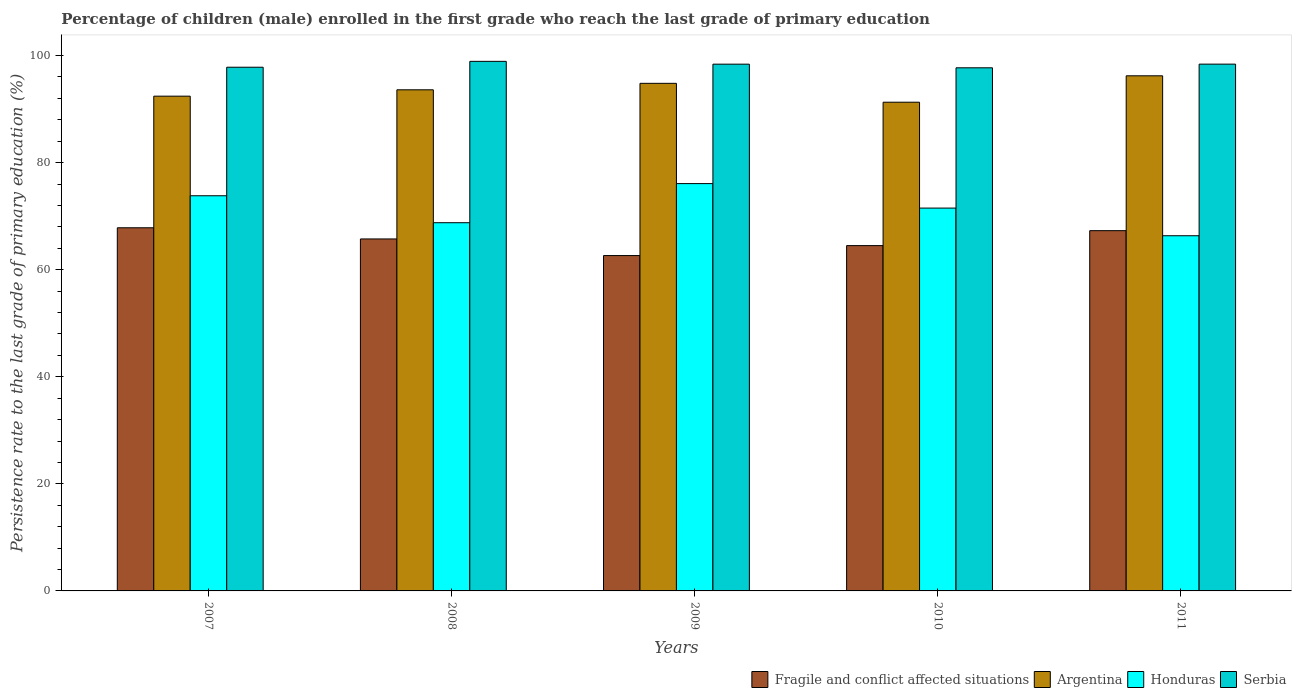How many bars are there on the 4th tick from the left?
Make the answer very short. 4. In how many cases, is the number of bars for a given year not equal to the number of legend labels?
Your response must be concise. 0. What is the persistence rate of children in Serbia in 2009?
Provide a succinct answer. 98.39. Across all years, what is the maximum persistence rate of children in Fragile and conflict affected situations?
Keep it short and to the point. 67.83. Across all years, what is the minimum persistence rate of children in Fragile and conflict affected situations?
Provide a succinct answer. 62.64. In which year was the persistence rate of children in Fragile and conflict affected situations minimum?
Provide a short and direct response. 2009. What is the total persistence rate of children in Fragile and conflict affected situations in the graph?
Your answer should be compact. 327.99. What is the difference between the persistence rate of children in Honduras in 2007 and that in 2011?
Offer a very short reply. 7.47. What is the difference between the persistence rate of children in Argentina in 2008 and the persistence rate of children in Fragile and conflict affected situations in 2010?
Keep it short and to the point. 29.1. What is the average persistence rate of children in Serbia per year?
Provide a succinct answer. 98.24. In the year 2011, what is the difference between the persistence rate of children in Honduras and persistence rate of children in Fragile and conflict affected situations?
Your answer should be compact. -0.95. In how many years, is the persistence rate of children in Fragile and conflict affected situations greater than 12 %?
Offer a terse response. 5. What is the ratio of the persistence rate of children in Honduras in 2009 to that in 2011?
Ensure brevity in your answer.  1.15. Is the difference between the persistence rate of children in Honduras in 2008 and 2011 greater than the difference between the persistence rate of children in Fragile and conflict affected situations in 2008 and 2011?
Provide a short and direct response. Yes. What is the difference between the highest and the second highest persistence rate of children in Serbia?
Ensure brevity in your answer.  0.52. What is the difference between the highest and the lowest persistence rate of children in Honduras?
Your answer should be compact. 9.74. In how many years, is the persistence rate of children in Fragile and conflict affected situations greater than the average persistence rate of children in Fragile and conflict affected situations taken over all years?
Offer a very short reply. 3. Is it the case that in every year, the sum of the persistence rate of children in Serbia and persistence rate of children in Argentina is greater than the sum of persistence rate of children in Fragile and conflict affected situations and persistence rate of children in Honduras?
Provide a short and direct response. Yes. What does the 4th bar from the left in 2007 represents?
Give a very brief answer. Serbia. What does the 4th bar from the right in 2010 represents?
Make the answer very short. Fragile and conflict affected situations. Is it the case that in every year, the sum of the persistence rate of children in Fragile and conflict affected situations and persistence rate of children in Serbia is greater than the persistence rate of children in Honduras?
Your answer should be very brief. Yes. How many bars are there?
Give a very brief answer. 20. Are all the bars in the graph horizontal?
Your answer should be very brief. No. How many years are there in the graph?
Your response must be concise. 5. Does the graph contain any zero values?
Make the answer very short. No. How are the legend labels stacked?
Provide a succinct answer. Horizontal. What is the title of the graph?
Your answer should be very brief. Percentage of children (male) enrolled in the first grade who reach the last grade of primary education. What is the label or title of the Y-axis?
Your answer should be very brief. Persistence rate to the last grade of primary education (%). What is the Persistence rate to the last grade of primary education (%) of Fragile and conflict affected situations in 2007?
Your answer should be compact. 67.83. What is the Persistence rate to the last grade of primary education (%) of Argentina in 2007?
Make the answer very short. 92.41. What is the Persistence rate to the last grade of primary education (%) in Honduras in 2007?
Provide a short and direct response. 73.81. What is the Persistence rate to the last grade of primary education (%) in Serbia in 2007?
Your response must be concise. 97.82. What is the Persistence rate to the last grade of primary education (%) of Fragile and conflict affected situations in 2008?
Offer a terse response. 65.74. What is the Persistence rate to the last grade of primary education (%) in Argentina in 2008?
Provide a short and direct response. 93.6. What is the Persistence rate to the last grade of primary education (%) in Honduras in 2008?
Keep it short and to the point. 68.77. What is the Persistence rate to the last grade of primary education (%) in Serbia in 2008?
Keep it short and to the point. 98.91. What is the Persistence rate to the last grade of primary education (%) of Fragile and conflict affected situations in 2009?
Give a very brief answer. 62.64. What is the Persistence rate to the last grade of primary education (%) in Argentina in 2009?
Keep it short and to the point. 94.81. What is the Persistence rate to the last grade of primary education (%) of Honduras in 2009?
Ensure brevity in your answer.  76.08. What is the Persistence rate to the last grade of primary education (%) of Serbia in 2009?
Keep it short and to the point. 98.39. What is the Persistence rate to the last grade of primary education (%) of Fragile and conflict affected situations in 2010?
Make the answer very short. 64.5. What is the Persistence rate to the last grade of primary education (%) in Argentina in 2010?
Your response must be concise. 91.28. What is the Persistence rate to the last grade of primary education (%) in Honduras in 2010?
Your answer should be compact. 71.51. What is the Persistence rate to the last grade of primary education (%) of Serbia in 2010?
Make the answer very short. 97.71. What is the Persistence rate to the last grade of primary education (%) in Fragile and conflict affected situations in 2011?
Your answer should be compact. 67.29. What is the Persistence rate to the last grade of primary education (%) of Argentina in 2011?
Make the answer very short. 96.21. What is the Persistence rate to the last grade of primary education (%) of Honduras in 2011?
Your answer should be very brief. 66.34. What is the Persistence rate to the last grade of primary education (%) in Serbia in 2011?
Give a very brief answer. 98.39. Across all years, what is the maximum Persistence rate to the last grade of primary education (%) in Fragile and conflict affected situations?
Make the answer very short. 67.83. Across all years, what is the maximum Persistence rate to the last grade of primary education (%) in Argentina?
Provide a short and direct response. 96.21. Across all years, what is the maximum Persistence rate to the last grade of primary education (%) in Honduras?
Your response must be concise. 76.08. Across all years, what is the maximum Persistence rate to the last grade of primary education (%) of Serbia?
Give a very brief answer. 98.91. Across all years, what is the minimum Persistence rate to the last grade of primary education (%) in Fragile and conflict affected situations?
Your answer should be compact. 62.64. Across all years, what is the minimum Persistence rate to the last grade of primary education (%) in Argentina?
Provide a short and direct response. 91.28. Across all years, what is the minimum Persistence rate to the last grade of primary education (%) in Honduras?
Provide a short and direct response. 66.34. Across all years, what is the minimum Persistence rate to the last grade of primary education (%) of Serbia?
Your answer should be compact. 97.71. What is the total Persistence rate to the last grade of primary education (%) of Fragile and conflict affected situations in the graph?
Ensure brevity in your answer.  327.99. What is the total Persistence rate to the last grade of primary education (%) of Argentina in the graph?
Keep it short and to the point. 468.31. What is the total Persistence rate to the last grade of primary education (%) in Honduras in the graph?
Your response must be concise. 356.51. What is the total Persistence rate to the last grade of primary education (%) of Serbia in the graph?
Give a very brief answer. 491.22. What is the difference between the Persistence rate to the last grade of primary education (%) of Fragile and conflict affected situations in 2007 and that in 2008?
Offer a very short reply. 2.09. What is the difference between the Persistence rate to the last grade of primary education (%) of Argentina in 2007 and that in 2008?
Give a very brief answer. -1.19. What is the difference between the Persistence rate to the last grade of primary education (%) of Honduras in 2007 and that in 2008?
Offer a terse response. 5.03. What is the difference between the Persistence rate to the last grade of primary education (%) in Serbia in 2007 and that in 2008?
Offer a very short reply. -1.1. What is the difference between the Persistence rate to the last grade of primary education (%) in Fragile and conflict affected situations in 2007 and that in 2009?
Keep it short and to the point. 5.19. What is the difference between the Persistence rate to the last grade of primary education (%) of Argentina in 2007 and that in 2009?
Your answer should be compact. -2.4. What is the difference between the Persistence rate to the last grade of primary education (%) in Honduras in 2007 and that in 2009?
Give a very brief answer. -2.27. What is the difference between the Persistence rate to the last grade of primary education (%) in Serbia in 2007 and that in 2009?
Your response must be concise. -0.57. What is the difference between the Persistence rate to the last grade of primary education (%) in Fragile and conflict affected situations in 2007 and that in 2010?
Make the answer very short. 3.33. What is the difference between the Persistence rate to the last grade of primary education (%) in Argentina in 2007 and that in 2010?
Keep it short and to the point. 1.13. What is the difference between the Persistence rate to the last grade of primary education (%) of Honduras in 2007 and that in 2010?
Provide a short and direct response. 2.3. What is the difference between the Persistence rate to the last grade of primary education (%) of Serbia in 2007 and that in 2010?
Your answer should be compact. 0.11. What is the difference between the Persistence rate to the last grade of primary education (%) of Fragile and conflict affected situations in 2007 and that in 2011?
Offer a very short reply. 0.54. What is the difference between the Persistence rate to the last grade of primary education (%) of Argentina in 2007 and that in 2011?
Your response must be concise. -3.8. What is the difference between the Persistence rate to the last grade of primary education (%) of Honduras in 2007 and that in 2011?
Keep it short and to the point. 7.47. What is the difference between the Persistence rate to the last grade of primary education (%) in Serbia in 2007 and that in 2011?
Offer a very short reply. -0.58. What is the difference between the Persistence rate to the last grade of primary education (%) in Fragile and conflict affected situations in 2008 and that in 2009?
Give a very brief answer. 3.11. What is the difference between the Persistence rate to the last grade of primary education (%) in Argentina in 2008 and that in 2009?
Give a very brief answer. -1.21. What is the difference between the Persistence rate to the last grade of primary education (%) in Honduras in 2008 and that in 2009?
Your answer should be compact. -7.31. What is the difference between the Persistence rate to the last grade of primary education (%) of Serbia in 2008 and that in 2009?
Provide a succinct answer. 0.52. What is the difference between the Persistence rate to the last grade of primary education (%) in Fragile and conflict affected situations in 2008 and that in 2010?
Offer a terse response. 1.24. What is the difference between the Persistence rate to the last grade of primary education (%) in Argentina in 2008 and that in 2010?
Provide a succinct answer. 2.32. What is the difference between the Persistence rate to the last grade of primary education (%) in Honduras in 2008 and that in 2010?
Give a very brief answer. -2.73. What is the difference between the Persistence rate to the last grade of primary education (%) in Serbia in 2008 and that in 2010?
Your response must be concise. 1.21. What is the difference between the Persistence rate to the last grade of primary education (%) in Fragile and conflict affected situations in 2008 and that in 2011?
Ensure brevity in your answer.  -1.55. What is the difference between the Persistence rate to the last grade of primary education (%) in Argentina in 2008 and that in 2011?
Keep it short and to the point. -2.62. What is the difference between the Persistence rate to the last grade of primary education (%) in Honduras in 2008 and that in 2011?
Your answer should be very brief. 2.43. What is the difference between the Persistence rate to the last grade of primary education (%) in Serbia in 2008 and that in 2011?
Keep it short and to the point. 0.52. What is the difference between the Persistence rate to the last grade of primary education (%) of Fragile and conflict affected situations in 2009 and that in 2010?
Your response must be concise. -1.86. What is the difference between the Persistence rate to the last grade of primary education (%) of Argentina in 2009 and that in 2010?
Your response must be concise. 3.53. What is the difference between the Persistence rate to the last grade of primary education (%) of Honduras in 2009 and that in 2010?
Your response must be concise. 4.57. What is the difference between the Persistence rate to the last grade of primary education (%) in Serbia in 2009 and that in 2010?
Ensure brevity in your answer.  0.68. What is the difference between the Persistence rate to the last grade of primary education (%) in Fragile and conflict affected situations in 2009 and that in 2011?
Make the answer very short. -4.65. What is the difference between the Persistence rate to the last grade of primary education (%) of Argentina in 2009 and that in 2011?
Offer a very short reply. -1.41. What is the difference between the Persistence rate to the last grade of primary education (%) of Honduras in 2009 and that in 2011?
Ensure brevity in your answer.  9.74. What is the difference between the Persistence rate to the last grade of primary education (%) of Serbia in 2009 and that in 2011?
Ensure brevity in your answer.  -0. What is the difference between the Persistence rate to the last grade of primary education (%) of Fragile and conflict affected situations in 2010 and that in 2011?
Your response must be concise. -2.79. What is the difference between the Persistence rate to the last grade of primary education (%) in Argentina in 2010 and that in 2011?
Make the answer very short. -4.93. What is the difference between the Persistence rate to the last grade of primary education (%) of Honduras in 2010 and that in 2011?
Offer a terse response. 5.17. What is the difference between the Persistence rate to the last grade of primary education (%) in Serbia in 2010 and that in 2011?
Keep it short and to the point. -0.69. What is the difference between the Persistence rate to the last grade of primary education (%) of Fragile and conflict affected situations in 2007 and the Persistence rate to the last grade of primary education (%) of Argentina in 2008?
Give a very brief answer. -25.77. What is the difference between the Persistence rate to the last grade of primary education (%) of Fragile and conflict affected situations in 2007 and the Persistence rate to the last grade of primary education (%) of Honduras in 2008?
Your answer should be very brief. -0.94. What is the difference between the Persistence rate to the last grade of primary education (%) of Fragile and conflict affected situations in 2007 and the Persistence rate to the last grade of primary education (%) of Serbia in 2008?
Provide a succinct answer. -31.08. What is the difference between the Persistence rate to the last grade of primary education (%) in Argentina in 2007 and the Persistence rate to the last grade of primary education (%) in Honduras in 2008?
Give a very brief answer. 23.64. What is the difference between the Persistence rate to the last grade of primary education (%) in Argentina in 2007 and the Persistence rate to the last grade of primary education (%) in Serbia in 2008?
Provide a succinct answer. -6.5. What is the difference between the Persistence rate to the last grade of primary education (%) in Honduras in 2007 and the Persistence rate to the last grade of primary education (%) in Serbia in 2008?
Make the answer very short. -25.1. What is the difference between the Persistence rate to the last grade of primary education (%) in Fragile and conflict affected situations in 2007 and the Persistence rate to the last grade of primary education (%) in Argentina in 2009?
Provide a short and direct response. -26.98. What is the difference between the Persistence rate to the last grade of primary education (%) in Fragile and conflict affected situations in 2007 and the Persistence rate to the last grade of primary education (%) in Honduras in 2009?
Offer a very short reply. -8.25. What is the difference between the Persistence rate to the last grade of primary education (%) of Fragile and conflict affected situations in 2007 and the Persistence rate to the last grade of primary education (%) of Serbia in 2009?
Offer a very short reply. -30.56. What is the difference between the Persistence rate to the last grade of primary education (%) in Argentina in 2007 and the Persistence rate to the last grade of primary education (%) in Honduras in 2009?
Provide a succinct answer. 16.33. What is the difference between the Persistence rate to the last grade of primary education (%) of Argentina in 2007 and the Persistence rate to the last grade of primary education (%) of Serbia in 2009?
Your answer should be compact. -5.98. What is the difference between the Persistence rate to the last grade of primary education (%) of Honduras in 2007 and the Persistence rate to the last grade of primary education (%) of Serbia in 2009?
Provide a succinct answer. -24.58. What is the difference between the Persistence rate to the last grade of primary education (%) of Fragile and conflict affected situations in 2007 and the Persistence rate to the last grade of primary education (%) of Argentina in 2010?
Give a very brief answer. -23.45. What is the difference between the Persistence rate to the last grade of primary education (%) in Fragile and conflict affected situations in 2007 and the Persistence rate to the last grade of primary education (%) in Honduras in 2010?
Offer a very short reply. -3.68. What is the difference between the Persistence rate to the last grade of primary education (%) of Fragile and conflict affected situations in 2007 and the Persistence rate to the last grade of primary education (%) of Serbia in 2010?
Your answer should be very brief. -29.88. What is the difference between the Persistence rate to the last grade of primary education (%) of Argentina in 2007 and the Persistence rate to the last grade of primary education (%) of Honduras in 2010?
Offer a terse response. 20.9. What is the difference between the Persistence rate to the last grade of primary education (%) of Argentina in 2007 and the Persistence rate to the last grade of primary education (%) of Serbia in 2010?
Make the answer very short. -5.3. What is the difference between the Persistence rate to the last grade of primary education (%) of Honduras in 2007 and the Persistence rate to the last grade of primary education (%) of Serbia in 2010?
Provide a short and direct response. -23.9. What is the difference between the Persistence rate to the last grade of primary education (%) in Fragile and conflict affected situations in 2007 and the Persistence rate to the last grade of primary education (%) in Argentina in 2011?
Offer a terse response. -28.38. What is the difference between the Persistence rate to the last grade of primary education (%) of Fragile and conflict affected situations in 2007 and the Persistence rate to the last grade of primary education (%) of Honduras in 2011?
Provide a short and direct response. 1.49. What is the difference between the Persistence rate to the last grade of primary education (%) in Fragile and conflict affected situations in 2007 and the Persistence rate to the last grade of primary education (%) in Serbia in 2011?
Provide a succinct answer. -30.56. What is the difference between the Persistence rate to the last grade of primary education (%) of Argentina in 2007 and the Persistence rate to the last grade of primary education (%) of Honduras in 2011?
Keep it short and to the point. 26.07. What is the difference between the Persistence rate to the last grade of primary education (%) of Argentina in 2007 and the Persistence rate to the last grade of primary education (%) of Serbia in 2011?
Provide a succinct answer. -5.98. What is the difference between the Persistence rate to the last grade of primary education (%) in Honduras in 2007 and the Persistence rate to the last grade of primary education (%) in Serbia in 2011?
Your response must be concise. -24.59. What is the difference between the Persistence rate to the last grade of primary education (%) in Fragile and conflict affected situations in 2008 and the Persistence rate to the last grade of primary education (%) in Argentina in 2009?
Make the answer very short. -29.06. What is the difference between the Persistence rate to the last grade of primary education (%) of Fragile and conflict affected situations in 2008 and the Persistence rate to the last grade of primary education (%) of Honduras in 2009?
Keep it short and to the point. -10.34. What is the difference between the Persistence rate to the last grade of primary education (%) in Fragile and conflict affected situations in 2008 and the Persistence rate to the last grade of primary education (%) in Serbia in 2009?
Your answer should be very brief. -32.65. What is the difference between the Persistence rate to the last grade of primary education (%) in Argentina in 2008 and the Persistence rate to the last grade of primary education (%) in Honduras in 2009?
Make the answer very short. 17.52. What is the difference between the Persistence rate to the last grade of primary education (%) of Argentina in 2008 and the Persistence rate to the last grade of primary education (%) of Serbia in 2009?
Offer a very short reply. -4.79. What is the difference between the Persistence rate to the last grade of primary education (%) in Honduras in 2008 and the Persistence rate to the last grade of primary education (%) in Serbia in 2009?
Provide a succinct answer. -29.62. What is the difference between the Persistence rate to the last grade of primary education (%) of Fragile and conflict affected situations in 2008 and the Persistence rate to the last grade of primary education (%) of Argentina in 2010?
Offer a very short reply. -25.54. What is the difference between the Persistence rate to the last grade of primary education (%) of Fragile and conflict affected situations in 2008 and the Persistence rate to the last grade of primary education (%) of Honduras in 2010?
Your answer should be very brief. -5.77. What is the difference between the Persistence rate to the last grade of primary education (%) of Fragile and conflict affected situations in 2008 and the Persistence rate to the last grade of primary education (%) of Serbia in 2010?
Offer a terse response. -31.97. What is the difference between the Persistence rate to the last grade of primary education (%) of Argentina in 2008 and the Persistence rate to the last grade of primary education (%) of Honduras in 2010?
Your answer should be very brief. 22.09. What is the difference between the Persistence rate to the last grade of primary education (%) of Argentina in 2008 and the Persistence rate to the last grade of primary education (%) of Serbia in 2010?
Keep it short and to the point. -4.11. What is the difference between the Persistence rate to the last grade of primary education (%) in Honduras in 2008 and the Persistence rate to the last grade of primary education (%) in Serbia in 2010?
Keep it short and to the point. -28.93. What is the difference between the Persistence rate to the last grade of primary education (%) of Fragile and conflict affected situations in 2008 and the Persistence rate to the last grade of primary education (%) of Argentina in 2011?
Provide a succinct answer. -30.47. What is the difference between the Persistence rate to the last grade of primary education (%) in Fragile and conflict affected situations in 2008 and the Persistence rate to the last grade of primary education (%) in Honduras in 2011?
Provide a short and direct response. -0.6. What is the difference between the Persistence rate to the last grade of primary education (%) of Fragile and conflict affected situations in 2008 and the Persistence rate to the last grade of primary education (%) of Serbia in 2011?
Give a very brief answer. -32.65. What is the difference between the Persistence rate to the last grade of primary education (%) of Argentina in 2008 and the Persistence rate to the last grade of primary education (%) of Honduras in 2011?
Offer a very short reply. 27.26. What is the difference between the Persistence rate to the last grade of primary education (%) in Argentina in 2008 and the Persistence rate to the last grade of primary education (%) in Serbia in 2011?
Your answer should be very brief. -4.8. What is the difference between the Persistence rate to the last grade of primary education (%) in Honduras in 2008 and the Persistence rate to the last grade of primary education (%) in Serbia in 2011?
Your response must be concise. -29.62. What is the difference between the Persistence rate to the last grade of primary education (%) of Fragile and conflict affected situations in 2009 and the Persistence rate to the last grade of primary education (%) of Argentina in 2010?
Your response must be concise. -28.65. What is the difference between the Persistence rate to the last grade of primary education (%) in Fragile and conflict affected situations in 2009 and the Persistence rate to the last grade of primary education (%) in Honduras in 2010?
Keep it short and to the point. -8.87. What is the difference between the Persistence rate to the last grade of primary education (%) of Fragile and conflict affected situations in 2009 and the Persistence rate to the last grade of primary education (%) of Serbia in 2010?
Provide a succinct answer. -35.07. What is the difference between the Persistence rate to the last grade of primary education (%) in Argentina in 2009 and the Persistence rate to the last grade of primary education (%) in Honduras in 2010?
Your response must be concise. 23.3. What is the difference between the Persistence rate to the last grade of primary education (%) of Argentina in 2009 and the Persistence rate to the last grade of primary education (%) of Serbia in 2010?
Keep it short and to the point. -2.9. What is the difference between the Persistence rate to the last grade of primary education (%) of Honduras in 2009 and the Persistence rate to the last grade of primary education (%) of Serbia in 2010?
Offer a terse response. -21.63. What is the difference between the Persistence rate to the last grade of primary education (%) in Fragile and conflict affected situations in 2009 and the Persistence rate to the last grade of primary education (%) in Argentina in 2011?
Your answer should be very brief. -33.58. What is the difference between the Persistence rate to the last grade of primary education (%) in Fragile and conflict affected situations in 2009 and the Persistence rate to the last grade of primary education (%) in Honduras in 2011?
Your answer should be compact. -3.71. What is the difference between the Persistence rate to the last grade of primary education (%) in Fragile and conflict affected situations in 2009 and the Persistence rate to the last grade of primary education (%) in Serbia in 2011?
Your response must be concise. -35.76. What is the difference between the Persistence rate to the last grade of primary education (%) in Argentina in 2009 and the Persistence rate to the last grade of primary education (%) in Honduras in 2011?
Give a very brief answer. 28.46. What is the difference between the Persistence rate to the last grade of primary education (%) in Argentina in 2009 and the Persistence rate to the last grade of primary education (%) in Serbia in 2011?
Provide a short and direct response. -3.59. What is the difference between the Persistence rate to the last grade of primary education (%) of Honduras in 2009 and the Persistence rate to the last grade of primary education (%) of Serbia in 2011?
Provide a succinct answer. -22.31. What is the difference between the Persistence rate to the last grade of primary education (%) in Fragile and conflict affected situations in 2010 and the Persistence rate to the last grade of primary education (%) in Argentina in 2011?
Your response must be concise. -31.72. What is the difference between the Persistence rate to the last grade of primary education (%) in Fragile and conflict affected situations in 2010 and the Persistence rate to the last grade of primary education (%) in Honduras in 2011?
Make the answer very short. -1.84. What is the difference between the Persistence rate to the last grade of primary education (%) of Fragile and conflict affected situations in 2010 and the Persistence rate to the last grade of primary education (%) of Serbia in 2011?
Provide a succinct answer. -33.9. What is the difference between the Persistence rate to the last grade of primary education (%) in Argentina in 2010 and the Persistence rate to the last grade of primary education (%) in Honduras in 2011?
Offer a very short reply. 24.94. What is the difference between the Persistence rate to the last grade of primary education (%) of Argentina in 2010 and the Persistence rate to the last grade of primary education (%) of Serbia in 2011?
Offer a terse response. -7.11. What is the difference between the Persistence rate to the last grade of primary education (%) in Honduras in 2010 and the Persistence rate to the last grade of primary education (%) in Serbia in 2011?
Ensure brevity in your answer.  -26.89. What is the average Persistence rate to the last grade of primary education (%) of Fragile and conflict affected situations per year?
Your answer should be very brief. 65.6. What is the average Persistence rate to the last grade of primary education (%) of Argentina per year?
Make the answer very short. 93.66. What is the average Persistence rate to the last grade of primary education (%) of Honduras per year?
Your response must be concise. 71.3. What is the average Persistence rate to the last grade of primary education (%) in Serbia per year?
Your answer should be compact. 98.24. In the year 2007, what is the difference between the Persistence rate to the last grade of primary education (%) in Fragile and conflict affected situations and Persistence rate to the last grade of primary education (%) in Argentina?
Provide a short and direct response. -24.58. In the year 2007, what is the difference between the Persistence rate to the last grade of primary education (%) of Fragile and conflict affected situations and Persistence rate to the last grade of primary education (%) of Honduras?
Give a very brief answer. -5.98. In the year 2007, what is the difference between the Persistence rate to the last grade of primary education (%) of Fragile and conflict affected situations and Persistence rate to the last grade of primary education (%) of Serbia?
Ensure brevity in your answer.  -29.99. In the year 2007, what is the difference between the Persistence rate to the last grade of primary education (%) in Argentina and Persistence rate to the last grade of primary education (%) in Honduras?
Give a very brief answer. 18.6. In the year 2007, what is the difference between the Persistence rate to the last grade of primary education (%) in Argentina and Persistence rate to the last grade of primary education (%) in Serbia?
Your response must be concise. -5.41. In the year 2007, what is the difference between the Persistence rate to the last grade of primary education (%) in Honduras and Persistence rate to the last grade of primary education (%) in Serbia?
Give a very brief answer. -24.01. In the year 2008, what is the difference between the Persistence rate to the last grade of primary education (%) in Fragile and conflict affected situations and Persistence rate to the last grade of primary education (%) in Argentina?
Your answer should be compact. -27.86. In the year 2008, what is the difference between the Persistence rate to the last grade of primary education (%) of Fragile and conflict affected situations and Persistence rate to the last grade of primary education (%) of Honduras?
Give a very brief answer. -3.03. In the year 2008, what is the difference between the Persistence rate to the last grade of primary education (%) of Fragile and conflict affected situations and Persistence rate to the last grade of primary education (%) of Serbia?
Your answer should be compact. -33.17. In the year 2008, what is the difference between the Persistence rate to the last grade of primary education (%) of Argentina and Persistence rate to the last grade of primary education (%) of Honduras?
Offer a terse response. 24.82. In the year 2008, what is the difference between the Persistence rate to the last grade of primary education (%) of Argentina and Persistence rate to the last grade of primary education (%) of Serbia?
Ensure brevity in your answer.  -5.32. In the year 2008, what is the difference between the Persistence rate to the last grade of primary education (%) in Honduras and Persistence rate to the last grade of primary education (%) in Serbia?
Keep it short and to the point. -30.14. In the year 2009, what is the difference between the Persistence rate to the last grade of primary education (%) in Fragile and conflict affected situations and Persistence rate to the last grade of primary education (%) in Argentina?
Offer a very short reply. -32.17. In the year 2009, what is the difference between the Persistence rate to the last grade of primary education (%) in Fragile and conflict affected situations and Persistence rate to the last grade of primary education (%) in Honduras?
Provide a short and direct response. -13.44. In the year 2009, what is the difference between the Persistence rate to the last grade of primary education (%) of Fragile and conflict affected situations and Persistence rate to the last grade of primary education (%) of Serbia?
Provide a short and direct response. -35.75. In the year 2009, what is the difference between the Persistence rate to the last grade of primary education (%) in Argentina and Persistence rate to the last grade of primary education (%) in Honduras?
Your response must be concise. 18.73. In the year 2009, what is the difference between the Persistence rate to the last grade of primary education (%) in Argentina and Persistence rate to the last grade of primary education (%) in Serbia?
Ensure brevity in your answer.  -3.58. In the year 2009, what is the difference between the Persistence rate to the last grade of primary education (%) in Honduras and Persistence rate to the last grade of primary education (%) in Serbia?
Ensure brevity in your answer.  -22.31. In the year 2010, what is the difference between the Persistence rate to the last grade of primary education (%) in Fragile and conflict affected situations and Persistence rate to the last grade of primary education (%) in Argentina?
Offer a terse response. -26.78. In the year 2010, what is the difference between the Persistence rate to the last grade of primary education (%) of Fragile and conflict affected situations and Persistence rate to the last grade of primary education (%) of Honduras?
Your answer should be compact. -7.01. In the year 2010, what is the difference between the Persistence rate to the last grade of primary education (%) in Fragile and conflict affected situations and Persistence rate to the last grade of primary education (%) in Serbia?
Ensure brevity in your answer.  -33.21. In the year 2010, what is the difference between the Persistence rate to the last grade of primary education (%) of Argentina and Persistence rate to the last grade of primary education (%) of Honduras?
Your answer should be compact. 19.77. In the year 2010, what is the difference between the Persistence rate to the last grade of primary education (%) of Argentina and Persistence rate to the last grade of primary education (%) of Serbia?
Make the answer very short. -6.43. In the year 2010, what is the difference between the Persistence rate to the last grade of primary education (%) in Honduras and Persistence rate to the last grade of primary education (%) in Serbia?
Make the answer very short. -26.2. In the year 2011, what is the difference between the Persistence rate to the last grade of primary education (%) in Fragile and conflict affected situations and Persistence rate to the last grade of primary education (%) in Argentina?
Offer a very short reply. -28.93. In the year 2011, what is the difference between the Persistence rate to the last grade of primary education (%) of Fragile and conflict affected situations and Persistence rate to the last grade of primary education (%) of Honduras?
Make the answer very short. 0.95. In the year 2011, what is the difference between the Persistence rate to the last grade of primary education (%) in Fragile and conflict affected situations and Persistence rate to the last grade of primary education (%) in Serbia?
Offer a terse response. -31.11. In the year 2011, what is the difference between the Persistence rate to the last grade of primary education (%) of Argentina and Persistence rate to the last grade of primary education (%) of Honduras?
Make the answer very short. 29.87. In the year 2011, what is the difference between the Persistence rate to the last grade of primary education (%) of Argentina and Persistence rate to the last grade of primary education (%) of Serbia?
Make the answer very short. -2.18. In the year 2011, what is the difference between the Persistence rate to the last grade of primary education (%) of Honduras and Persistence rate to the last grade of primary education (%) of Serbia?
Your answer should be very brief. -32.05. What is the ratio of the Persistence rate to the last grade of primary education (%) of Fragile and conflict affected situations in 2007 to that in 2008?
Provide a succinct answer. 1.03. What is the ratio of the Persistence rate to the last grade of primary education (%) in Argentina in 2007 to that in 2008?
Provide a succinct answer. 0.99. What is the ratio of the Persistence rate to the last grade of primary education (%) in Honduras in 2007 to that in 2008?
Offer a very short reply. 1.07. What is the ratio of the Persistence rate to the last grade of primary education (%) in Serbia in 2007 to that in 2008?
Your answer should be compact. 0.99. What is the ratio of the Persistence rate to the last grade of primary education (%) in Fragile and conflict affected situations in 2007 to that in 2009?
Make the answer very short. 1.08. What is the ratio of the Persistence rate to the last grade of primary education (%) of Argentina in 2007 to that in 2009?
Offer a very short reply. 0.97. What is the ratio of the Persistence rate to the last grade of primary education (%) of Honduras in 2007 to that in 2009?
Make the answer very short. 0.97. What is the ratio of the Persistence rate to the last grade of primary education (%) of Serbia in 2007 to that in 2009?
Give a very brief answer. 0.99. What is the ratio of the Persistence rate to the last grade of primary education (%) of Fragile and conflict affected situations in 2007 to that in 2010?
Your answer should be very brief. 1.05. What is the ratio of the Persistence rate to the last grade of primary education (%) in Argentina in 2007 to that in 2010?
Your response must be concise. 1.01. What is the ratio of the Persistence rate to the last grade of primary education (%) in Honduras in 2007 to that in 2010?
Provide a short and direct response. 1.03. What is the ratio of the Persistence rate to the last grade of primary education (%) in Fragile and conflict affected situations in 2007 to that in 2011?
Offer a terse response. 1.01. What is the ratio of the Persistence rate to the last grade of primary education (%) in Argentina in 2007 to that in 2011?
Offer a very short reply. 0.96. What is the ratio of the Persistence rate to the last grade of primary education (%) of Honduras in 2007 to that in 2011?
Make the answer very short. 1.11. What is the ratio of the Persistence rate to the last grade of primary education (%) in Serbia in 2007 to that in 2011?
Your answer should be compact. 0.99. What is the ratio of the Persistence rate to the last grade of primary education (%) in Fragile and conflict affected situations in 2008 to that in 2009?
Offer a terse response. 1.05. What is the ratio of the Persistence rate to the last grade of primary education (%) of Argentina in 2008 to that in 2009?
Keep it short and to the point. 0.99. What is the ratio of the Persistence rate to the last grade of primary education (%) in Honduras in 2008 to that in 2009?
Ensure brevity in your answer.  0.9. What is the ratio of the Persistence rate to the last grade of primary education (%) in Fragile and conflict affected situations in 2008 to that in 2010?
Provide a succinct answer. 1.02. What is the ratio of the Persistence rate to the last grade of primary education (%) in Argentina in 2008 to that in 2010?
Provide a succinct answer. 1.03. What is the ratio of the Persistence rate to the last grade of primary education (%) of Honduras in 2008 to that in 2010?
Your answer should be very brief. 0.96. What is the ratio of the Persistence rate to the last grade of primary education (%) in Serbia in 2008 to that in 2010?
Your answer should be very brief. 1.01. What is the ratio of the Persistence rate to the last grade of primary education (%) in Fragile and conflict affected situations in 2008 to that in 2011?
Your answer should be compact. 0.98. What is the ratio of the Persistence rate to the last grade of primary education (%) of Argentina in 2008 to that in 2011?
Your answer should be compact. 0.97. What is the ratio of the Persistence rate to the last grade of primary education (%) in Honduras in 2008 to that in 2011?
Your answer should be compact. 1.04. What is the ratio of the Persistence rate to the last grade of primary education (%) in Fragile and conflict affected situations in 2009 to that in 2010?
Make the answer very short. 0.97. What is the ratio of the Persistence rate to the last grade of primary education (%) of Argentina in 2009 to that in 2010?
Keep it short and to the point. 1.04. What is the ratio of the Persistence rate to the last grade of primary education (%) in Honduras in 2009 to that in 2010?
Provide a succinct answer. 1.06. What is the ratio of the Persistence rate to the last grade of primary education (%) of Fragile and conflict affected situations in 2009 to that in 2011?
Your answer should be compact. 0.93. What is the ratio of the Persistence rate to the last grade of primary education (%) in Argentina in 2009 to that in 2011?
Keep it short and to the point. 0.99. What is the ratio of the Persistence rate to the last grade of primary education (%) in Honduras in 2009 to that in 2011?
Offer a very short reply. 1.15. What is the ratio of the Persistence rate to the last grade of primary education (%) of Fragile and conflict affected situations in 2010 to that in 2011?
Ensure brevity in your answer.  0.96. What is the ratio of the Persistence rate to the last grade of primary education (%) of Argentina in 2010 to that in 2011?
Offer a terse response. 0.95. What is the ratio of the Persistence rate to the last grade of primary education (%) of Honduras in 2010 to that in 2011?
Your response must be concise. 1.08. What is the ratio of the Persistence rate to the last grade of primary education (%) in Serbia in 2010 to that in 2011?
Your answer should be compact. 0.99. What is the difference between the highest and the second highest Persistence rate to the last grade of primary education (%) of Fragile and conflict affected situations?
Your answer should be very brief. 0.54. What is the difference between the highest and the second highest Persistence rate to the last grade of primary education (%) in Argentina?
Provide a succinct answer. 1.41. What is the difference between the highest and the second highest Persistence rate to the last grade of primary education (%) in Honduras?
Offer a very short reply. 2.27. What is the difference between the highest and the second highest Persistence rate to the last grade of primary education (%) of Serbia?
Give a very brief answer. 0.52. What is the difference between the highest and the lowest Persistence rate to the last grade of primary education (%) of Fragile and conflict affected situations?
Your answer should be very brief. 5.19. What is the difference between the highest and the lowest Persistence rate to the last grade of primary education (%) of Argentina?
Offer a terse response. 4.93. What is the difference between the highest and the lowest Persistence rate to the last grade of primary education (%) in Honduras?
Make the answer very short. 9.74. What is the difference between the highest and the lowest Persistence rate to the last grade of primary education (%) in Serbia?
Ensure brevity in your answer.  1.21. 